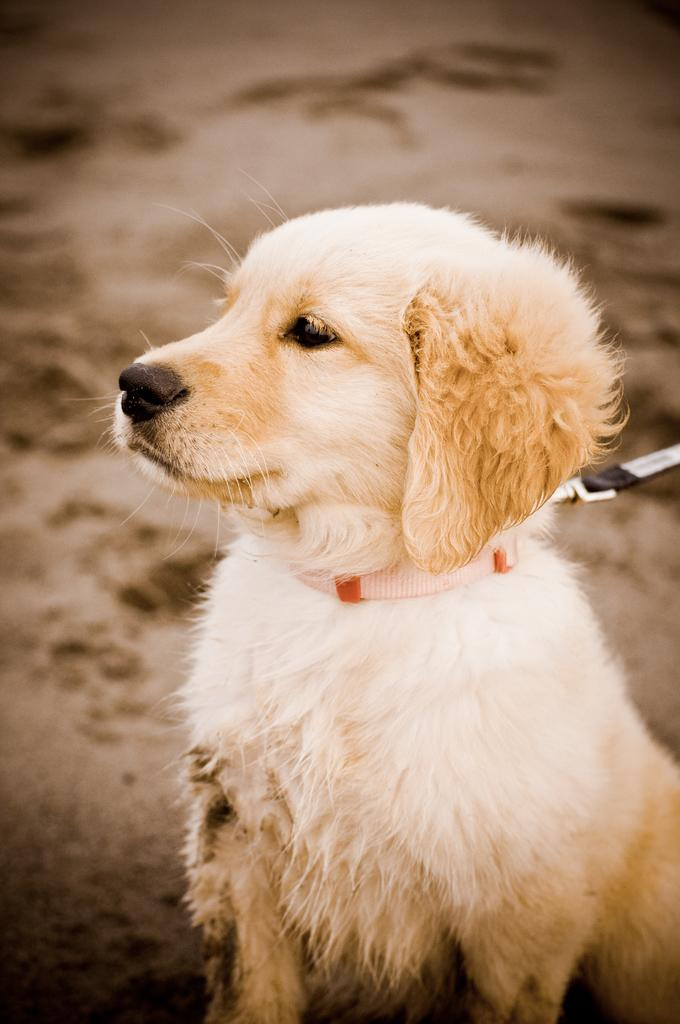What type of animal is present in the image? There is a dog in the image. Can you describe the background of the image? The background of the image is not clear. How does the fact increase the speed of the cart in the image? There is no fact, increase, or cart present in the image. 